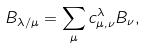Convert formula to latex. <formula><loc_0><loc_0><loc_500><loc_500>B _ { \lambda / \mu } = \sum _ { \mu } c ^ { \lambda } _ { \mu , \nu } B _ { \nu } ,</formula> 